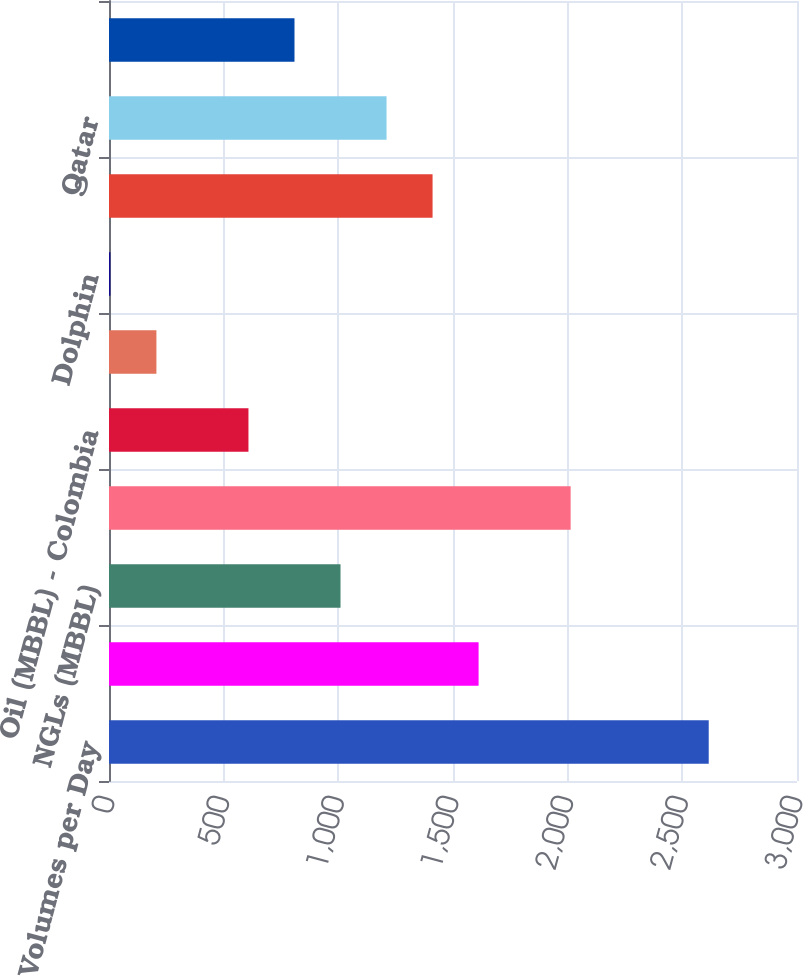Convert chart to OTSL. <chart><loc_0><loc_0><loc_500><loc_500><bar_chart><fcel>Sales Volumes per Day<fcel>Oil (MBBL)<fcel>NGLs (MBBL)<fcel>Natural gas (MMCF)<fcel>Oil (MBBL) - Colombia<fcel>Natural gas (MMCF) - Bolivia<fcel>Dolphin<fcel>Oman<fcel>Qatar<fcel>Other<nl><fcel>2615.1<fcel>1611.6<fcel>1009.5<fcel>2013<fcel>608.1<fcel>206.7<fcel>6<fcel>1410.9<fcel>1210.2<fcel>808.8<nl></chart> 